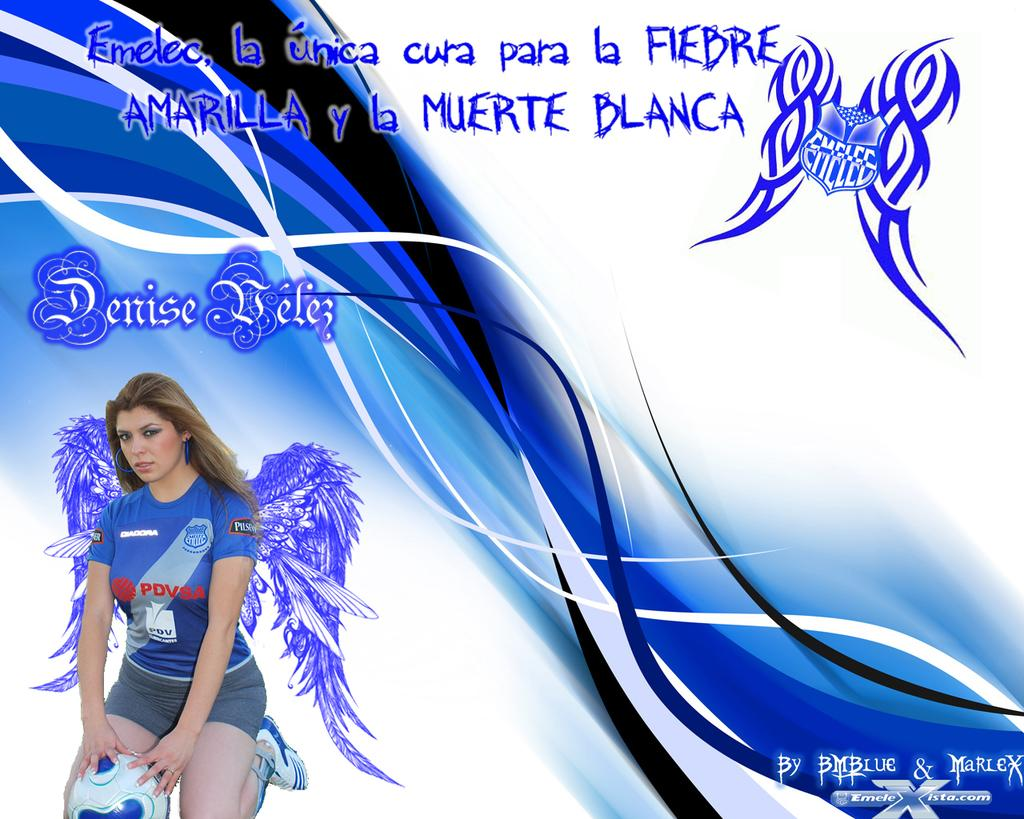Provide a one-sentence caption for the provided image. A picture of Denise Velez in a blue PDVSA shirt is on an ad for Amarilla y la Muerte Blanca. 